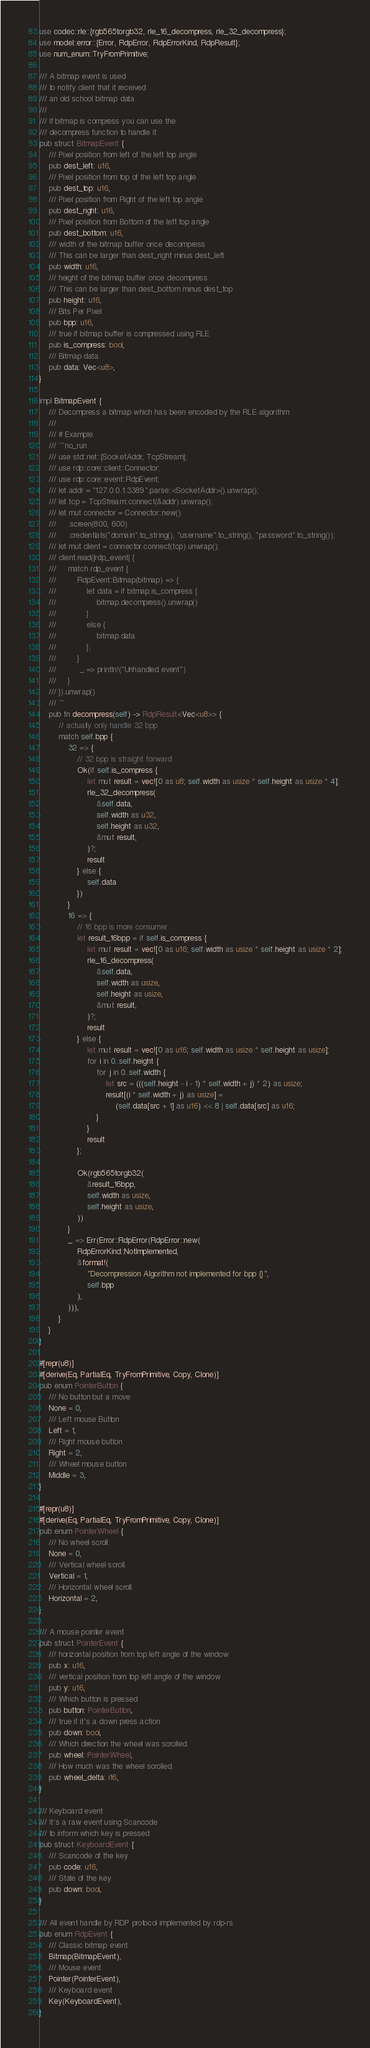<code> <loc_0><loc_0><loc_500><loc_500><_Rust_>use codec::rle::{rgb565torgb32, rle_16_decompress, rle_32_decompress};
use model::error::{Error, RdpError, RdpErrorKind, RdpResult};
use num_enum::TryFromPrimitive;

/// A bitmap event is used
/// to notify client that it received
/// an old school bitmap data
///
/// If bitmap is compress you can use the
/// decompress function to handle it
pub struct BitmapEvent {
    /// Pixel position from left of the left top angle
    pub dest_left: u16,
    /// Pixel position from top of the left top angle
    pub dest_top: u16,
    /// Pixel position from Right of the left top angle
    pub dest_right: u16,
    /// Pixel position from Bottom of the left top angle
    pub dest_bottom: u16,
    /// width of the bitmap buffer once decompress
    /// This can be larger than dest_right minus dest_left
    pub width: u16,
    /// height of the bitmap buffer once decompress
    /// This can be larger than dest_bottom minus dest_top
    pub height: u16,
    /// Bits Per Pixel
    pub bpp: u16,
    /// true if bitmap buffer is compressed using RLE
    pub is_compress: bool,
    /// Bitmap data
    pub data: Vec<u8>,
}

impl BitmapEvent {
    /// Decompress a bitmap which has been encoded by the RLE algorithm
    ///
    /// # Example
    /// ```no_run
    /// use std::net::{SocketAddr, TcpStream};
    /// use rdp::core::client::Connector;
    /// use rdp::core::event::RdpEvent;
    /// let addr = "127.0.0.1:3389".parse::<SocketAddr>().unwrap();
    /// let tcp = TcpStream::connect(&addr).unwrap();
    /// let mut connector = Connector::new()
    ///     .screen(800, 600)
    ///     .credentials("domain".to_string(), "username".to_string(), "password".to_string());
    /// let mut client = connector.connect(tcp).unwrap();
    /// client.read(|rdp_event| {
    ///     match rdp_event {
    ///         RdpEvent::Bitmap(bitmap) => {
    ///             let data = if bitmap.is_compress {
    ///                 bitmap.decompress().unwrap()
    ///             }
    ///             else {
    ///                 bitmap.data
    ///             };
    ///         }
    ///          _ => println!("Unhandled event")
    ///     }
    /// }).unwrap()
    /// ```
    pub fn decompress(self) -> RdpResult<Vec<u8>> {
        // actually only handle 32 bpp
        match self.bpp {
            32 => {
                // 32 bpp is straight forward
                Ok(if self.is_compress {
                    let mut result = vec![0 as u8; self.width as usize * self.height as usize * 4];
                    rle_32_decompress(
                        &self.data,
                        self.width as u32,
                        self.height as u32,
                        &mut result,
                    )?;
                    result
                } else {
                    self.data
                })
            }
            16 => {
                // 16 bpp is more consumer
                let result_16bpp = if self.is_compress {
                    let mut result = vec![0 as u16; self.width as usize * self.height as usize * 2];
                    rle_16_decompress(
                        &self.data,
                        self.width as usize,
                        self.height as usize,
                        &mut result,
                    )?;
                    result
                } else {
                    let mut result = vec![0 as u16; self.width as usize * self.height as usize];
                    for i in 0..self.height {
                        for j in 0..self.width {
                            let src = (((self.height - i - 1) * self.width + j) * 2) as usize;
                            result[(i * self.width + j) as usize] =
                                (self.data[src + 1] as u16) << 8 | self.data[src] as u16;
                        }
                    }
                    result
                };

                Ok(rgb565torgb32(
                    &result_16bpp,
                    self.width as usize,
                    self.height as usize,
                ))
            }
            _ => Err(Error::RdpError(RdpError::new(
                RdpErrorKind::NotImplemented,
                &format!(
                    "Decompression Algorithm not implemented for bpp {}",
                    self.bpp
                ),
            ))),
        }
    }
}

#[repr(u8)]
#[derive(Eq, PartialEq, TryFromPrimitive, Copy, Clone)]
pub enum PointerButton {
    /// No button but a move
    None = 0,
    /// Left mouse Button
    Left = 1,
    /// Right mouse button
    Right = 2,
    /// Wheel mouse button
    Middle = 3,
}

#[repr(u8)]
#[derive(Eq, PartialEq, TryFromPrimitive, Copy, Clone)]
pub enum PointerWheel {
    /// No wheel scroll.
    None = 0,
    /// Vertical wheel scroll.
    Vertical = 1,
    /// Horizontal wheel scroll.
    Horizontal = 2,
}

/// A mouse pointer event
pub struct PointerEvent {
    /// horizontal position from top left angle of the window
    pub x: u16,
    /// vertical position from top left angle of the window
    pub y: u16,
    /// Which button is pressed
    pub button: PointerButton,
    /// true if it's a down press action
    pub down: bool,
    /// Which direction the wheel was scrolled.
    pub wheel: PointerWheel,
    /// How much was the wheel scrolled.
    pub wheel_delta: i16,
}

/// Keyboard event
/// It's a raw event using Scancode
/// to inform which key is pressed
pub struct KeyboardEvent {
    /// Scancode of the key
    pub code: u16,
    /// State of the key
    pub down: bool,
}

/// All event handle by RDP protocol implemented by rdp-rs
pub enum RdpEvent {
    /// Classic bitmap event
    Bitmap(BitmapEvent),
    /// Mouse event
    Pointer(PointerEvent),
    /// Keyboard event
    Key(KeyboardEvent),
}
</code> 